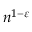<formula> <loc_0><loc_0><loc_500><loc_500>n ^ { 1 - \varepsilon }</formula> 